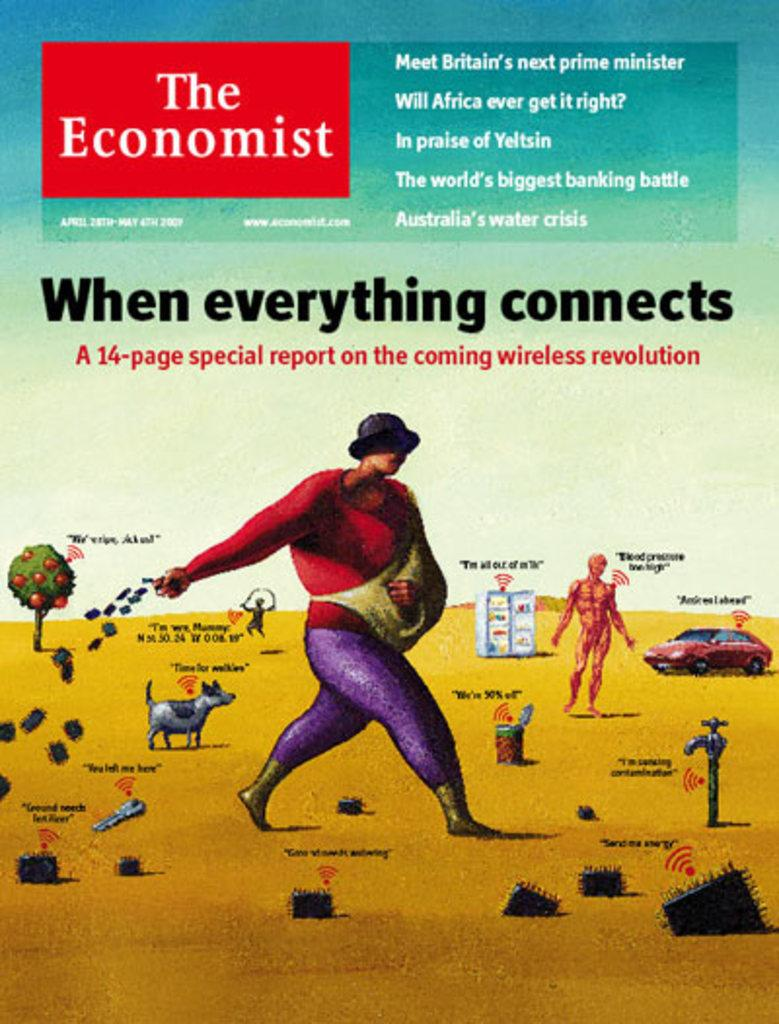<image>
Provide a brief description of the given image. The cover of The Economist magazine from the year 2009. 